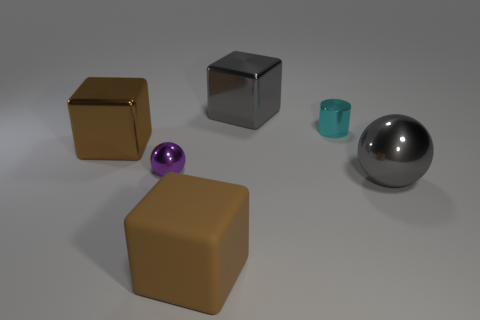The shiny thing that is on the right side of the large brown rubber cube and left of the cyan cylinder has what shape? The shiny object situated to the right of the large brown cube and to the left of the cyan cylinder is itself a cube, exhibiting a lustrous metallic surface that reflects light, distinguishing it from the matte texture of the other objects. 